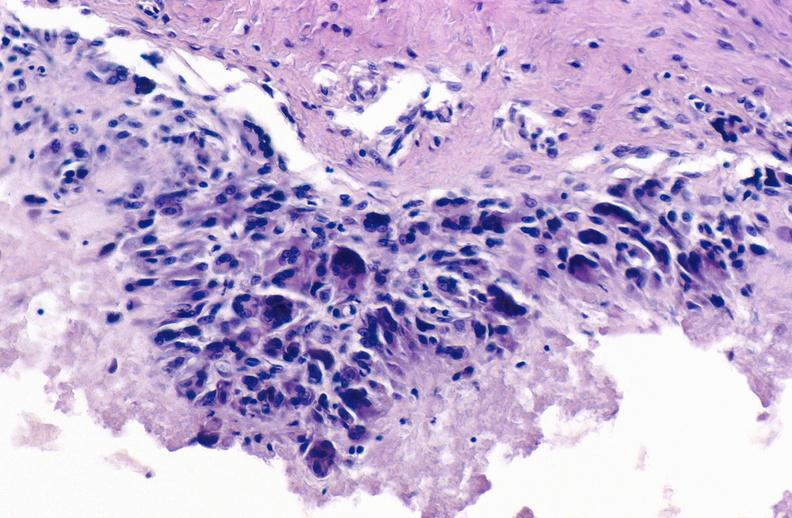what does this image show?
Answer the question using a single word or phrase. Gout 